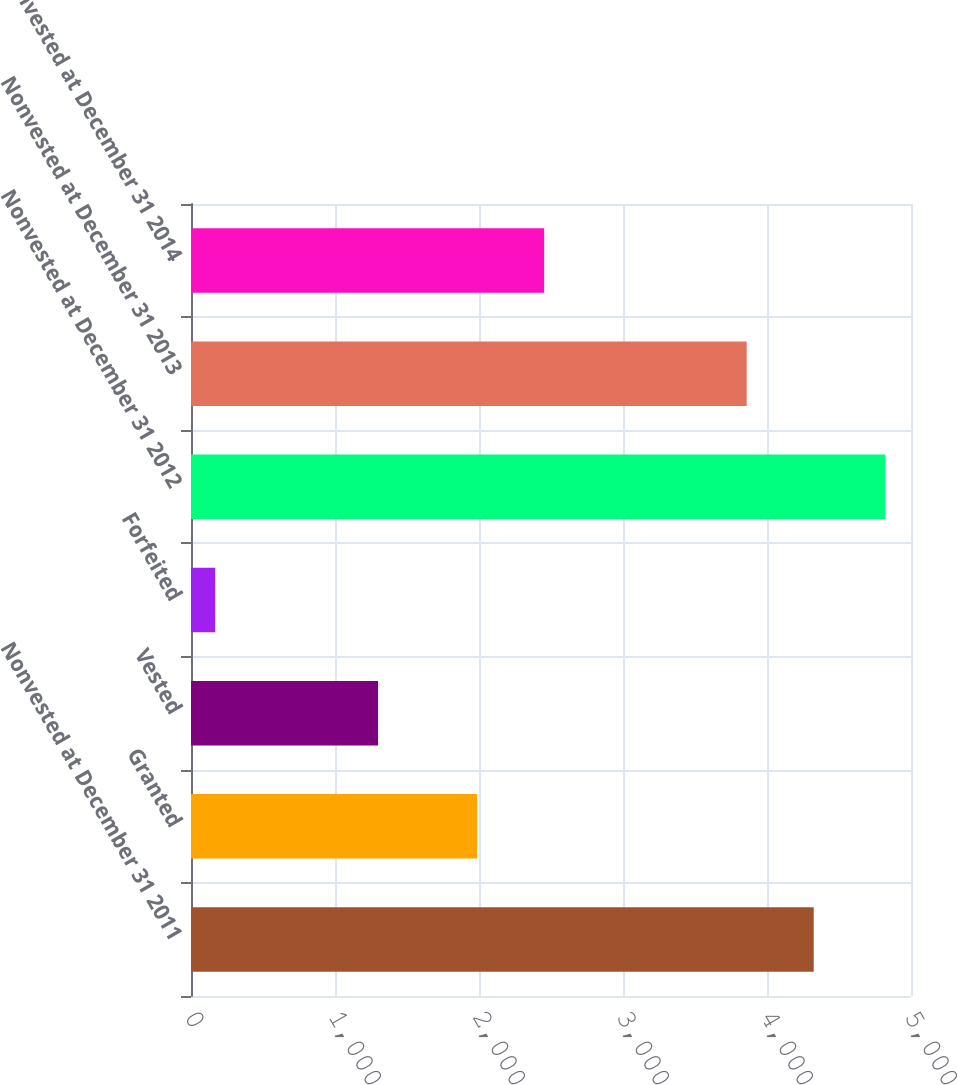<chart> <loc_0><loc_0><loc_500><loc_500><bar_chart><fcel>Nonvested at December 31 2011<fcel>Granted<fcel>Vested<fcel>Forfeited<fcel>Nonvested at December 31 2012<fcel>Nonvested at December 31 2013<fcel>Nonvested at December 31 2014<nl><fcel>4324.4<fcel>1987<fcel>1299<fcel>168<fcel>4822<fcel>3859<fcel>2452.4<nl></chart> 